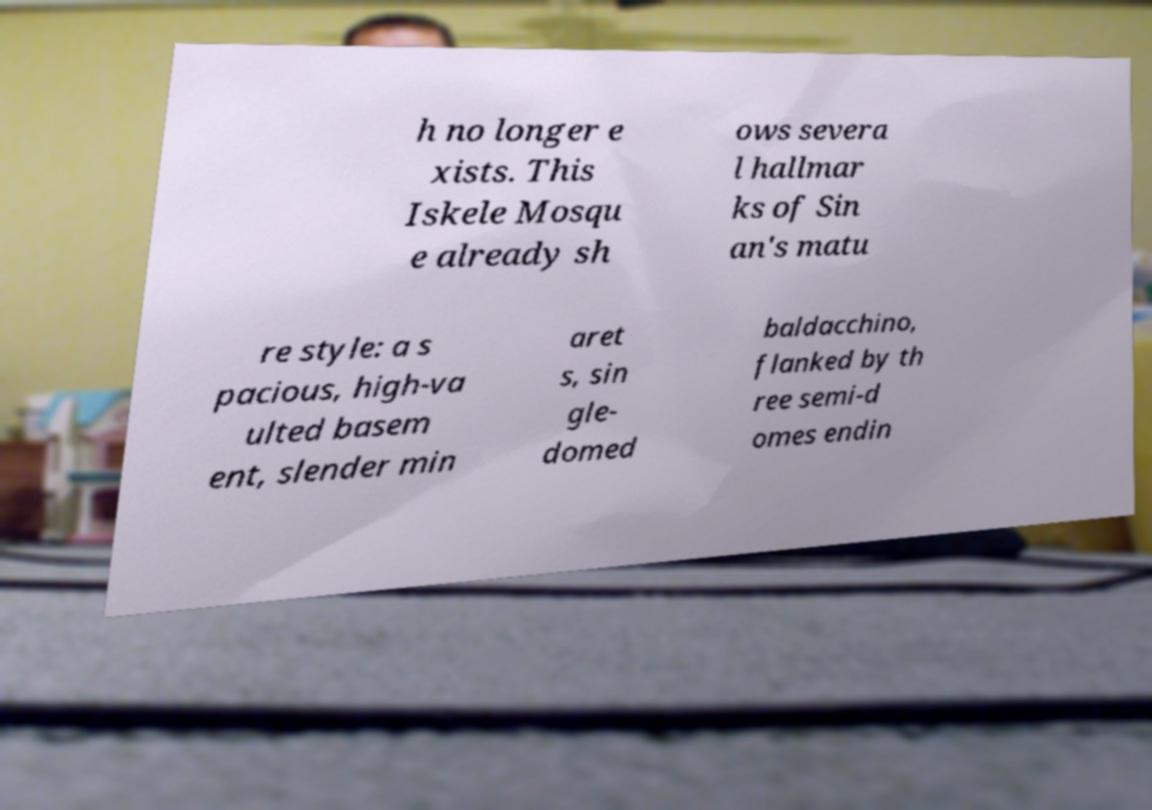I need the written content from this picture converted into text. Can you do that? h no longer e xists. This Iskele Mosqu e already sh ows severa l hallmar ks of Sin an's matu re style: a s pacious, high-va ulted basem ent, slender min aret s, sin gle- domed baldacchino, flanked by th ree semi-d omes endin 